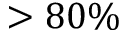Convert formula to latex. <formula><loc_0><loc_0><loc_500><loc_500>> 8 0 \%</formula> 